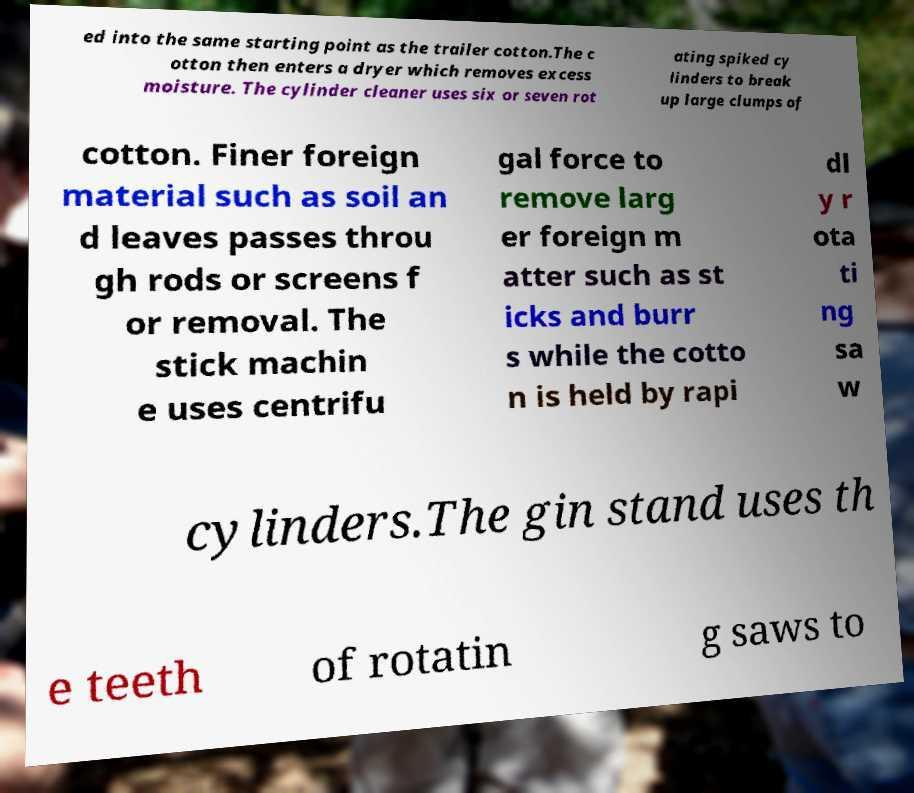I need the written content from this picture converted into text. Can you do that? ed into the same starting point as the trailer cotton.The c otton then enters a dryer which removes excess moisture. The cylinder cleaner uses six or seven rot ating spiked cy linders to break up large clumps of cotton. Finer foreign material such as soil an d leaves passes throu gh rods or screens f or removal. The stick machin e uses centrifu gal force to remove larg er foreign m atter such as st icks and burr s while the cotto n is held by rapi dl y r ota ti ng sa w cylinders.The gin stand uses th e teeth of rotatin g saws to 